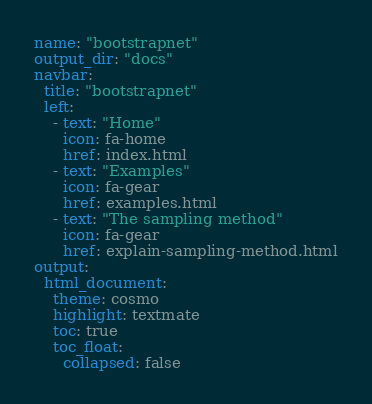<code> <loc_0><loc_0><loc_500><loc_500><_YAML_>name: "bootstrapnet"
output_dir: "docs"
navbar:
  title: "bootstrapnet"
  left:
    - text: "Home"
      icon: fa-home
      href: index.html
    - text: "Examples"
      icon: fa-gear
      href: examples.html
    - text: "The sampling method"
      icon: fa-gear
      href: explain-sampling-method.html
output:
  html_document:
    theme: cosmo
    highlight: textmate
    toc: true
    toc_float:
      collapsed: false
</code> 